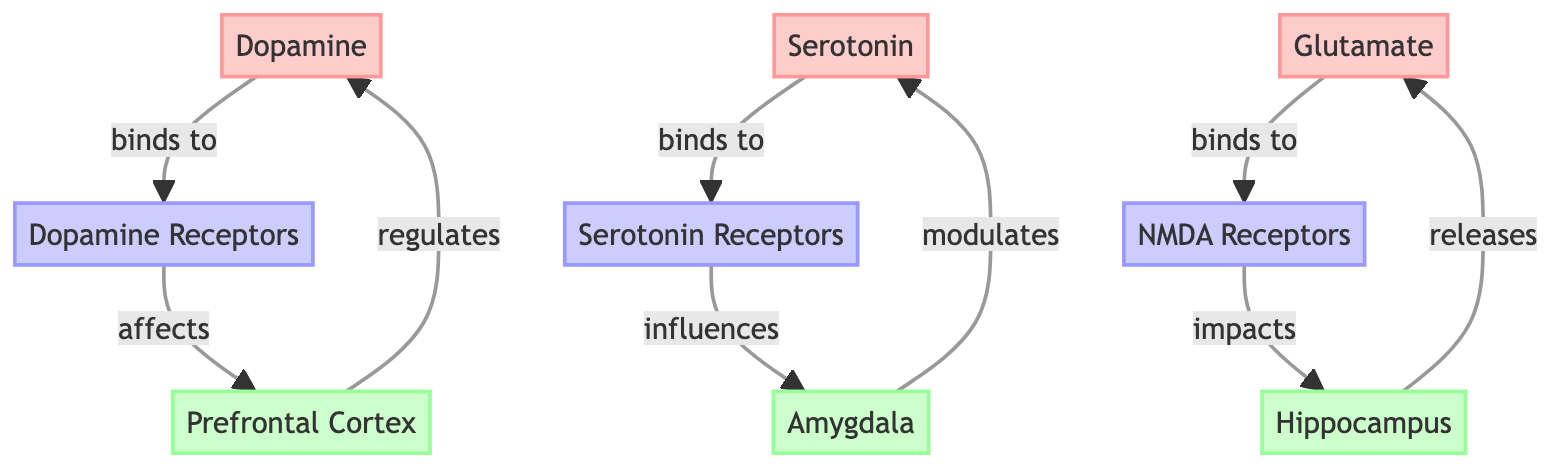What are the three neurotransmitters shown in the diagram? The diagram clearly lists three neurotransmitters: Dopamine, Serotonin, and Glutamate. These are distinguished by the color coding and labeled nodes.
Answer: Dopamine, Serotonin, Glutamate Which brain region is primarily regulated by Dopamine? According to the diagram, Dopamine is shown to directly influence the Prefrontal Cortex through the link indicating regulation.
Answer: Prefrontal Cortex How many receptors are associated with the neurotransmitters in the diagram? The diagram presents three types of receptors: Dopamine Receptors, Serotonin Receptors, and NMDA Receptors. Therefore, the total number of receptor types is three.
Answer: 3 Which region releases Glutamate? The diagram illustrates that the Hippocampus has an outbound link labeled "releases" indicating its role in releasing Glutamate.
Answer: Hippocampus How does Serotonin affect the Amygdala? The link in the diagram details that Serotonin directly influences the Amygdala through the Serotonin Receptors, indicating a causal effect of Serotonin on this brain region.
Answer: influences What is the relationship between NMDA Receptors and the Hippocampus? The diagram shows that NMDA Receptors have an impact on the Hippocampus, as indicated by the label "impacts," establishing a direct relationship that suggests NMDA receptor activity affects Hippocampal functions.
Answer: impacts Which neurotransmitter is modulated by the Amygdala? The diagram specifies that the Amygdala modulates Serotonin, as shown through the direct linking of the Amygdala to Serotonin with the label "modulates."
Answer: Serotonin How many directed links are there from neurotransmitters to their respective receptors? The diagram displays three links where each neurotransmitter connects to its receptor (Dopamine to Dopamine Receptors, Serotonin to Serotonin Receptors, and Glutamate to NMDA Receptors), totaling three directed links.
Answer: 3 What is the effect of Dopamine Receptors on the Prefrontal Cortex? The diagram outlines that Dopamine Receptors affect the Prefrontal Cortex, with a directional link labeled "affects," indicating that changes in Dopamine receptor activity have consequences on this brain area's function.
Answer: affects 